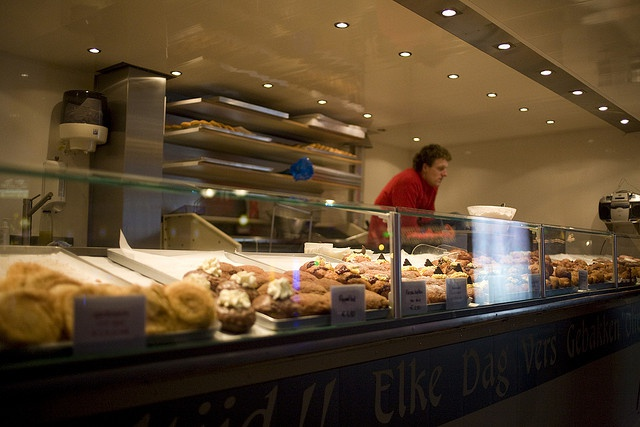Describe the objects in this image and their specific colors. I can see cake in black, olive, maroon, and tan tones, people in black, maroon, and brown tones, donut in black, olive, and orange tones, cake in black, brown, and maroon tones, and donut in black, tan, and maroon tones in this image. 